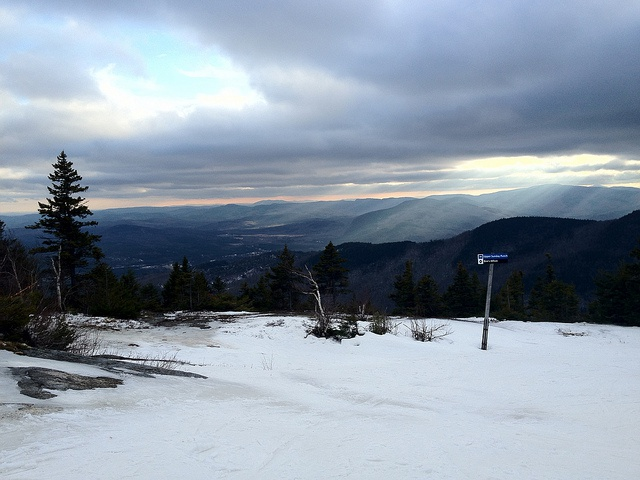Describe the objects in this image and their specific colors. I can see various objects in this image with different colors. 